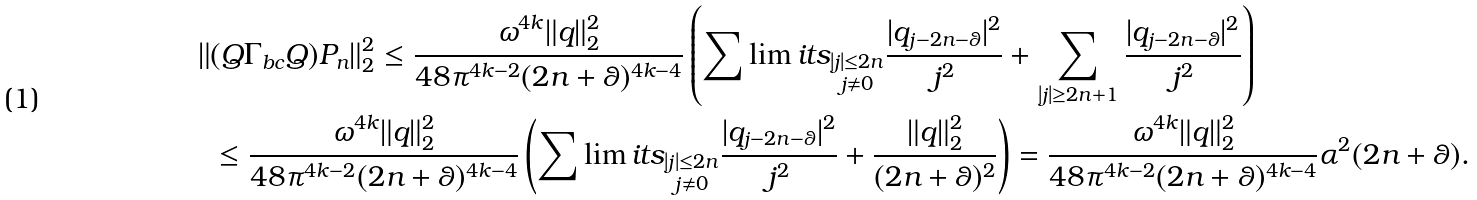Convert formula to latex. <formula><loc_0><loc_0><loc_500><loc_500>\| & ( Q \Gamma _ { b c } Q ) P _ { n } \| _ { 2 } ^ { 2 } \leq \frac { \omega ^ { 4 k } \| q \| _ { 2 } ^ { 2 } } { 4 8 \pi ^ { 4 k - 2 } ( 2 n + \theta ) ^ { 4 k - 4 } } \left ( \sum \lim i t s _ { \substack { | j | \leq 2 n \\ j \ne 0 } } \frac { | q _ { j - 2 n - \theta } | ^ { 2 } } { j ^ { 2 } } + \sum _ { | j | \geq 2 n + 1 } \frac { | q _ { j - 2 n - \theta } | ^ { 2 } } { j ^ { 2 } } \right ) \\ & \leq \frac { \omega ^ { 4 k } \| q \| _ { 2 } ^ { 2 } } { 4 8 \pi ^ { 4 k - 2 } ( 2 n + \theta ) ^ { 4 k - 4 } } \left ( \sum \lim i t s _ { \substack { | j | \leq 2 n \\ j \ne 0 } } \frac { | q _ { j - 2 n - \theta } | ^ { 2 } } { j ^ { 2 } } + \frac { \| q \| _ { 2 } ^ { 2 } } { ( 2 n + \theta ) ^ { 2 } } \right ) = \frac { \omega ^ { 4 k } \| q \| _ { 2 } ^ { 2 } } { 4 8 \pi ^ { 4 k - 2 } ( 2 n + \theta ) ^ { 4 k - 4 } } \alpha ^ { 2 } ( 2 n + \theta ) .</formula> 